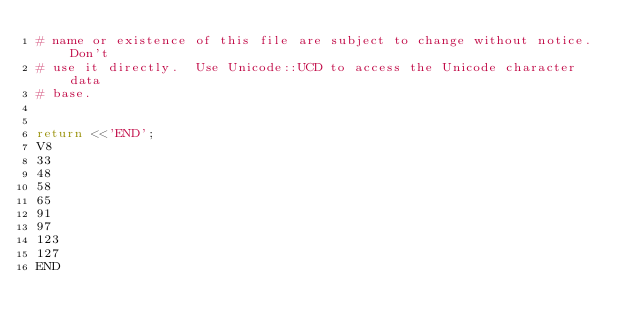Convert code to text. <code><loc_0><loc_0><loc_500><loc_500><_Perl_># name or existence of this file are subject to change without notice.  Don't
# use it directly.  Use Unicode::UCD to access the Unicode character data
# base.


return <<'END';
V8
33
48
58
65
91
97
123
127
END
</code> 